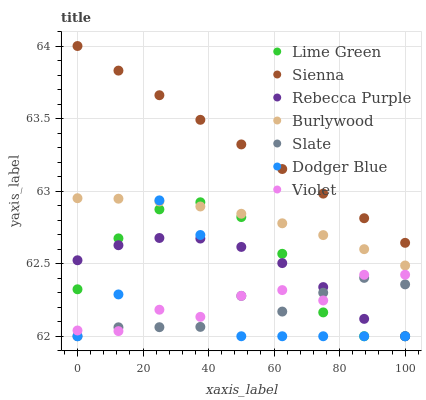Does Slate have the minimum area under the curve?
Answer yes or no. Yes. Does Sienna have the maximum area under the curve?
Answer yes or no. Yes. Does Sienna have the minimum area under the curve?
Answer yes or no. No. Does Slate have the maximum area under the curve?
Answer yes or no. No. Is Sienna the smoothest?
Answer yes or no. Yes. Is Dodger Blue the roughest?
Answer yes or no. Yes. Is Slate the smoothest?
Answer yes or no. No. Is Slate the roughest?
Answer yes or no. No. Does Slate have the lowest value?
Answer yes or no. Yes. Does Sienna have the lowest value?
Answer yes or no. No. Does Sienna have the highest value?
Answer yes or no. Yes. Does Slate have the highest value?
Answer yes or no. No. Is Violet less than Sienna?
Answer yes or no. Yes. Is Burlywood greater than Violet?
Answer yes or no. Yes. Does Burlywood intersect Lime Green?
Answer yes or no. Yes. Is Burlywood less than Lime Green?
Answer yes or no. No. Is Burlywood greater than Lime Green?
Answer yes or no. No. Does Violet intersect Sienna?
Answer yes or no. No. 